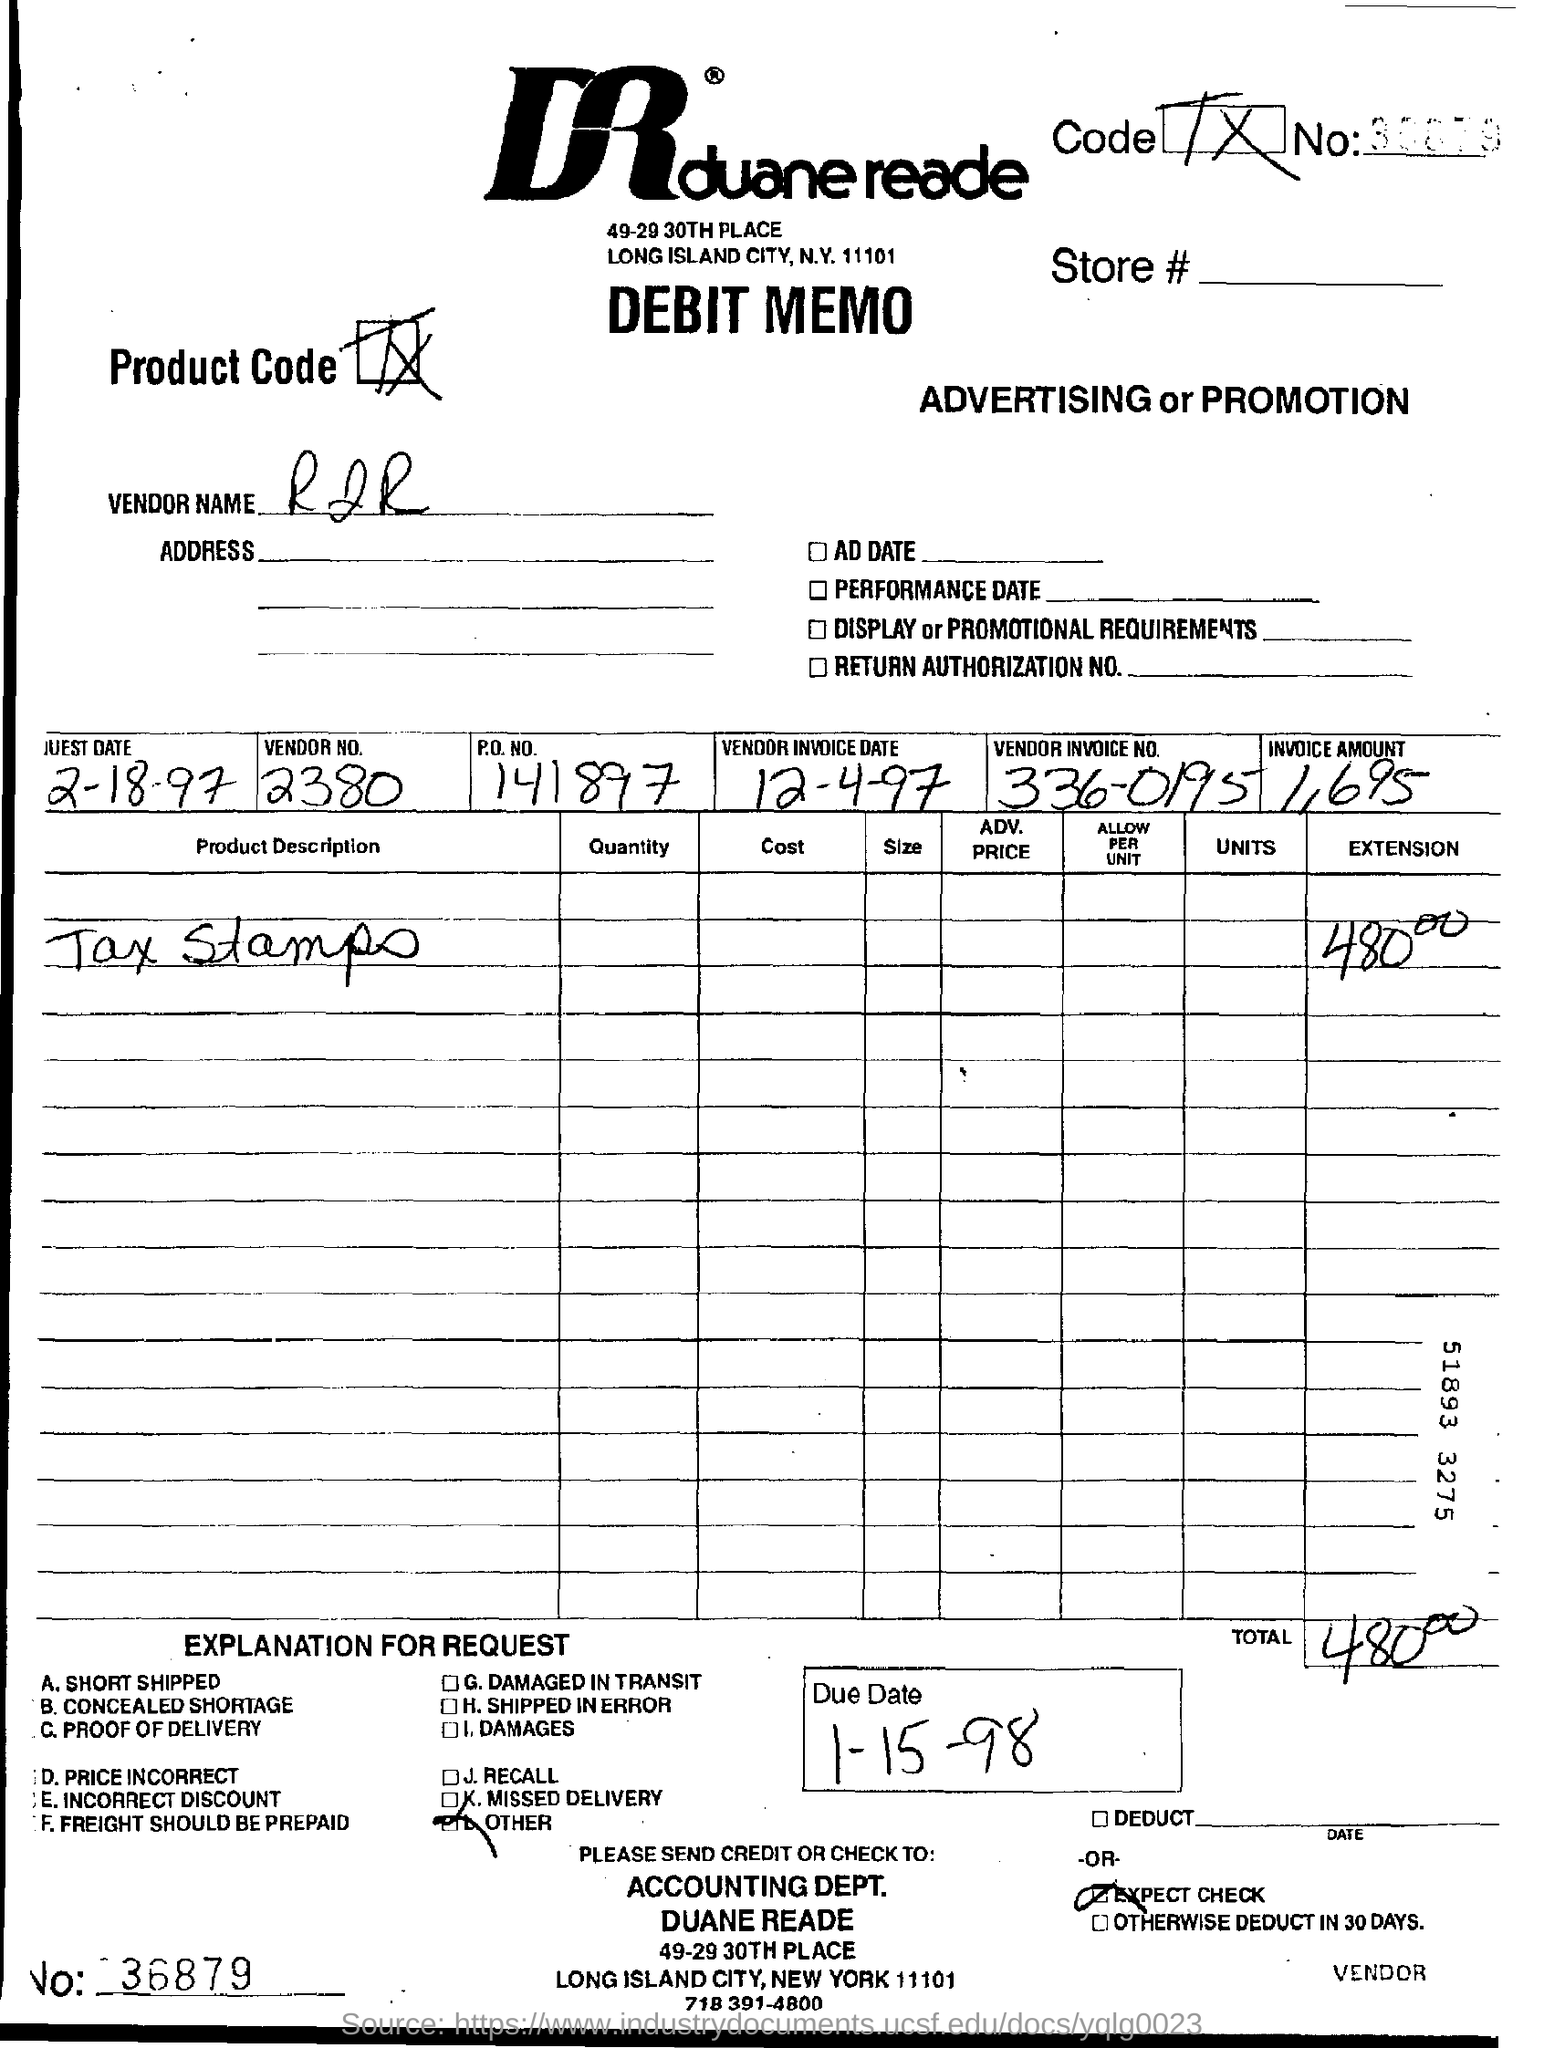Highlight a few significant elements in this photo. What is the vendor number for 2380?" is a question asking for information about a specific vendor and a specific product or service. The full sentence might be something like: "Please provide the vendor number for 2380, as we are trying to gather information about all of our vendors and their products. The vendor name is RJR. The product description mentions tax stamps. The invoice amount is 1,695. What is the P.O. number? 141897..." is a question that is asking for information about a post office number. 